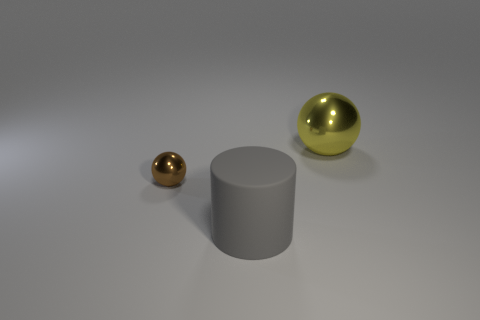Subtract all brown spheres. Subtract all blue cubes. How many spheres are left? 1 Add 2 shiny objects. How many objects exist? 5 Subtract all cylinders. How many objects are left? 2 Subtract 0 brown cubes. How many objects are left? 3 Subtract all tiny metal things. Subtract all gray rubber things. How many objects are left? 1 Add 1 large yellow balls. How many large yellow balls are left? 2 Add 2 small yellow matte objects. How many small yellow matte objects exist? 2 